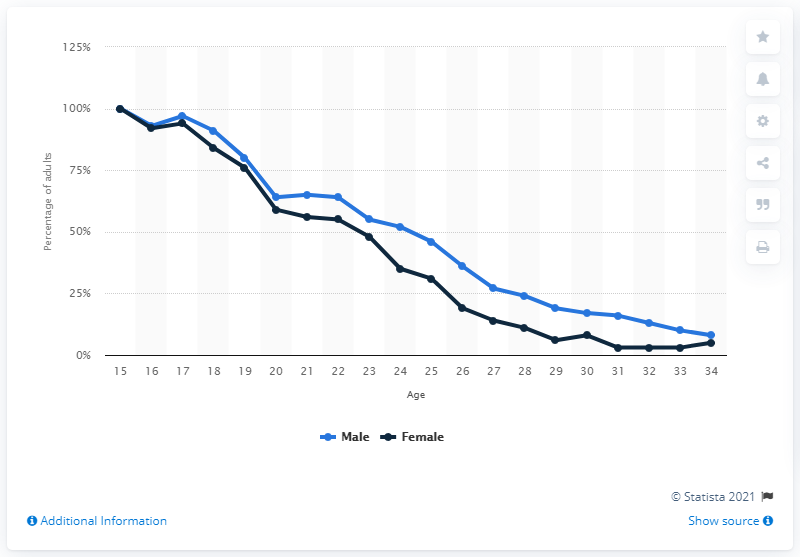Indicate a few pertinent items in this graphic. The majority of females in the UK who were living with their parents in 2020 were aged 25. 